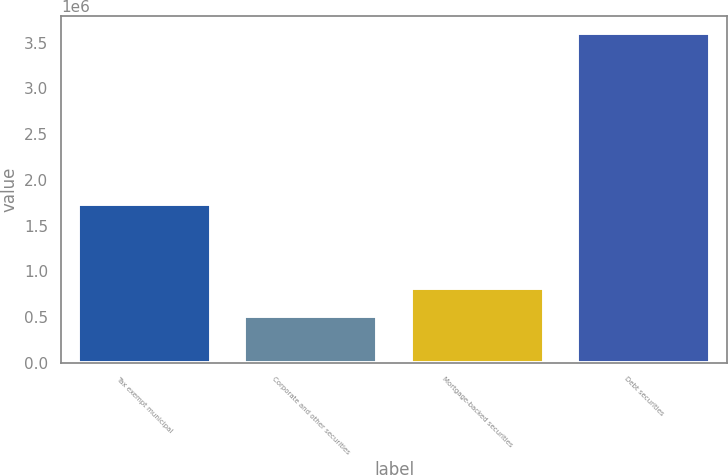Convert chart. <chart><loc_0><loc_0><loc_500><loc_500><bar_chart><fcel>Tax exempt municipal<fcel>Corporate and other securities<fcel>Mortgage-backed securities<fcel>Debt securities<nl><fcel>1.73516e+06<fcel>507385<fcel>817588<fcel>3.60941e+06<nl></chart> 